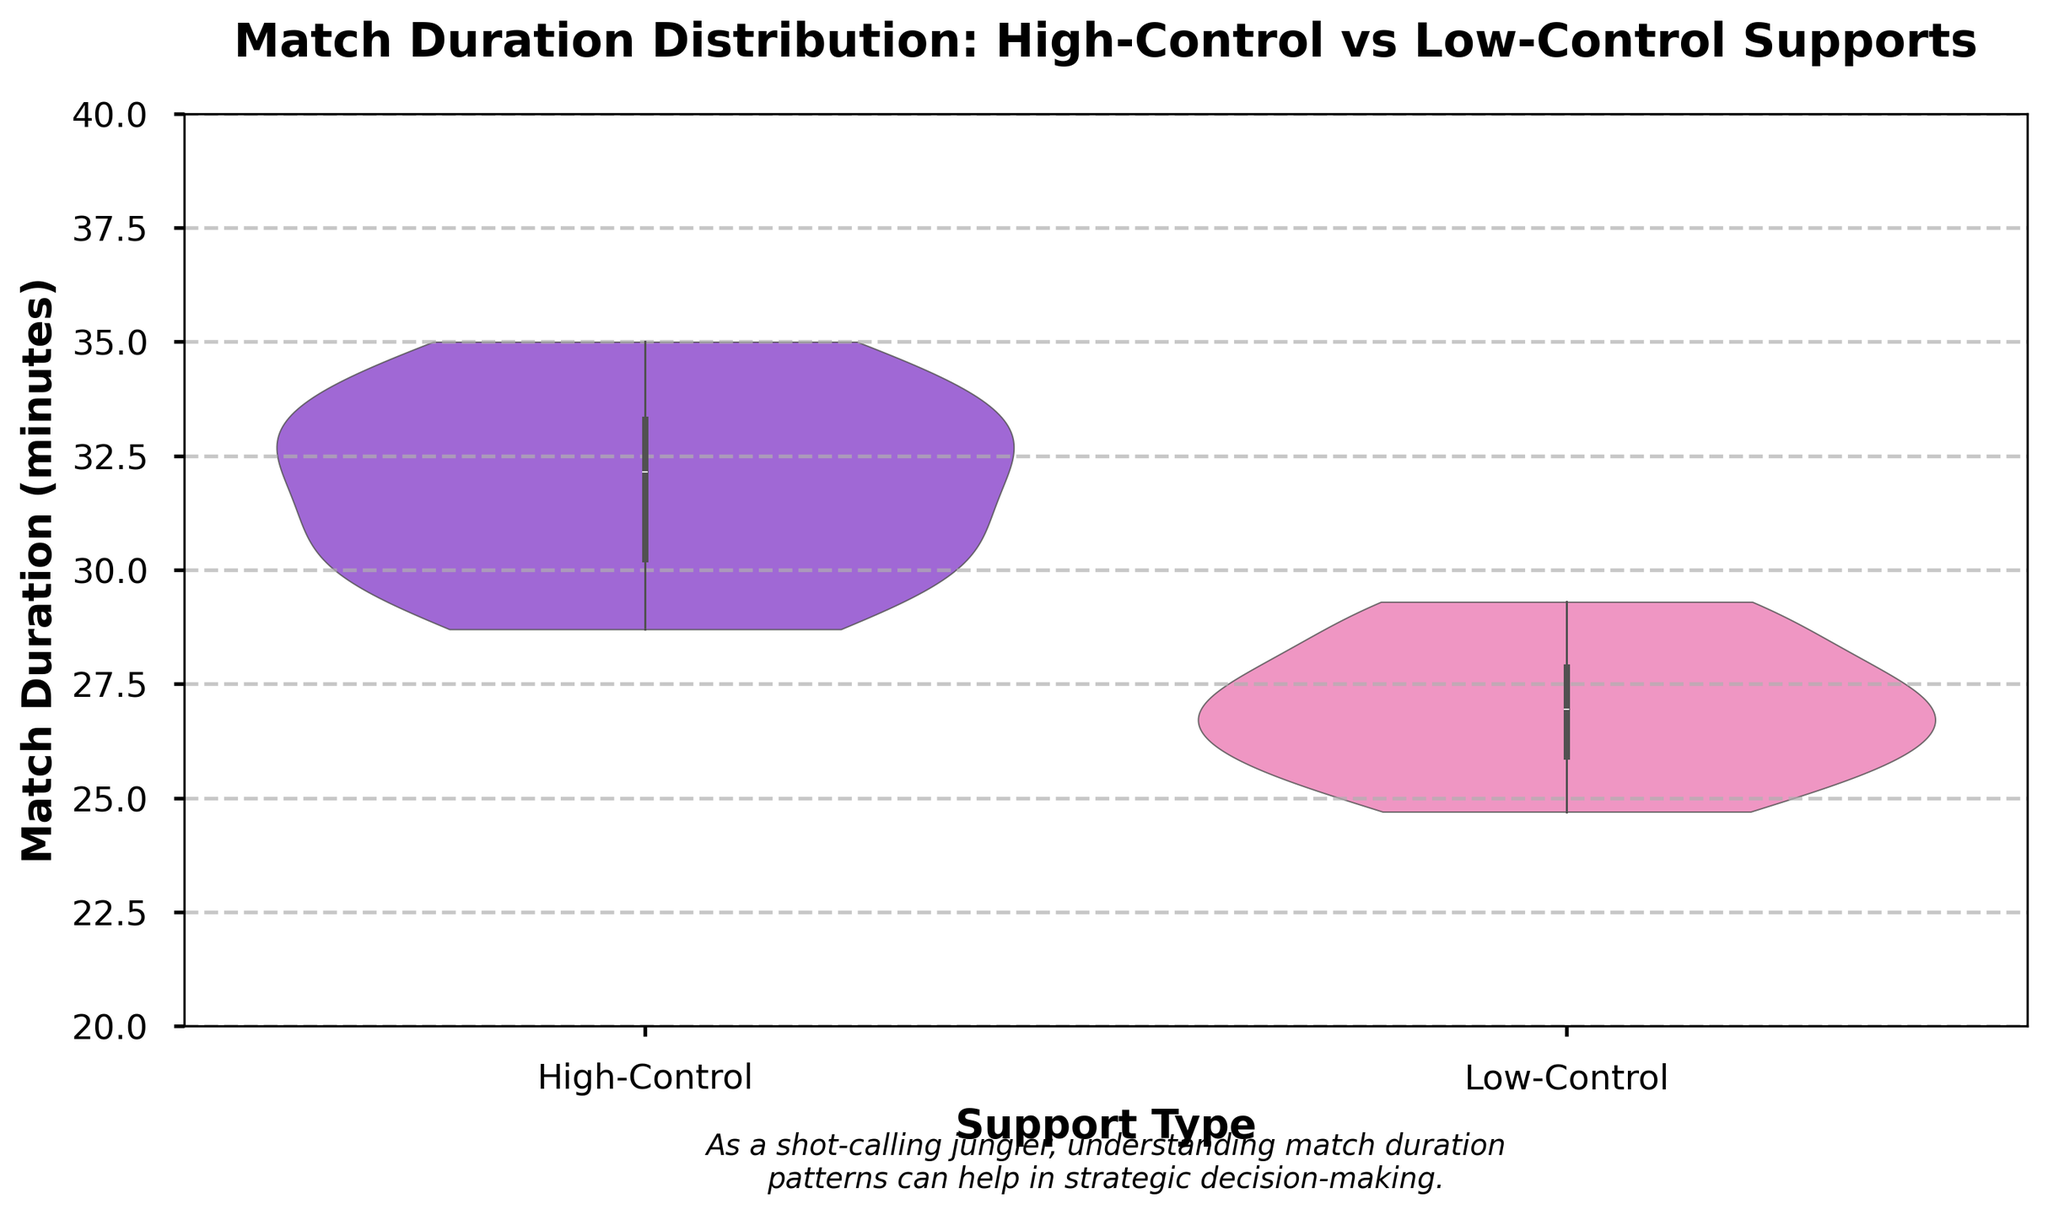What does the title of the figure indicate? The title provides a summary of the data comparison and distribution visualized in the plot. It suggests that the figure is about comparing match duration distributions between games with high-control supports and low-control supports.
Answer: Comparison of match duration distributions for high-control vs low-control supports What are the categories on the x-axis? The x-axis represents the types of supports: "High-Control" and "Low-Control". These categories partition the data accordingly.
Answer: High-Control, Low-Control What is the range of match durations shown on the y-axis? The y-axis shows match duration in minutes, ranging from 20 to 40. This is the limit set in the figure to help visualize data better.
Answer: 20 to 40 minutes How do the widths of the violins in the plot relate to the data distribution? The width of a violin at any point along the y-axis indicates the density of match durations at that particular value. Wider sections represent a higher concentration of data points.
Answer: Width indicates density of data points Which support type tends to have shorter match durations on average? By comparing the violins, the Low-Control support group generally shows shorter match durations as the main density is shifted lower compared to the High-Control group.
Answer: Low-Control What's the median match duration for the High-Control support? The median match duration is indicated by the thick white line within the High-Control violin.
Answer: Approximately 32 minutes How do the interquartile ranges (IQR) of the two support types compare? The interquartile range, depicted by the wider mid-section (inner box), seems larger for High-Control supports than Low-Control supports, suggesting more variability.
Answer: High-Control has a larger IQR What is the primary difference in match duration distribution between the high-control and low-control supports? The primary difference is that High-Control supports tend to have both higher median values and broader interquartile ranges, indicating longer and more variable match durations.
Answer: High-Control has longer and more variable match durations Between which values is the bulk of the match duration data for Low-Control supports concentrated? The bulk of the data for Low-Control supports is within the interquartile range, which appears to be roughly between 25 to 28 minutes.
Answer: 25 to 28 minutes How does the added text contribute to understanding the visualization? The added text emphasizes the strategic importance for a jungler to understand match duration patterns, which can aid in in-game decision-making. This contextualizes the importance of the data visualized.
Answer: Adds strategic context for junglers 